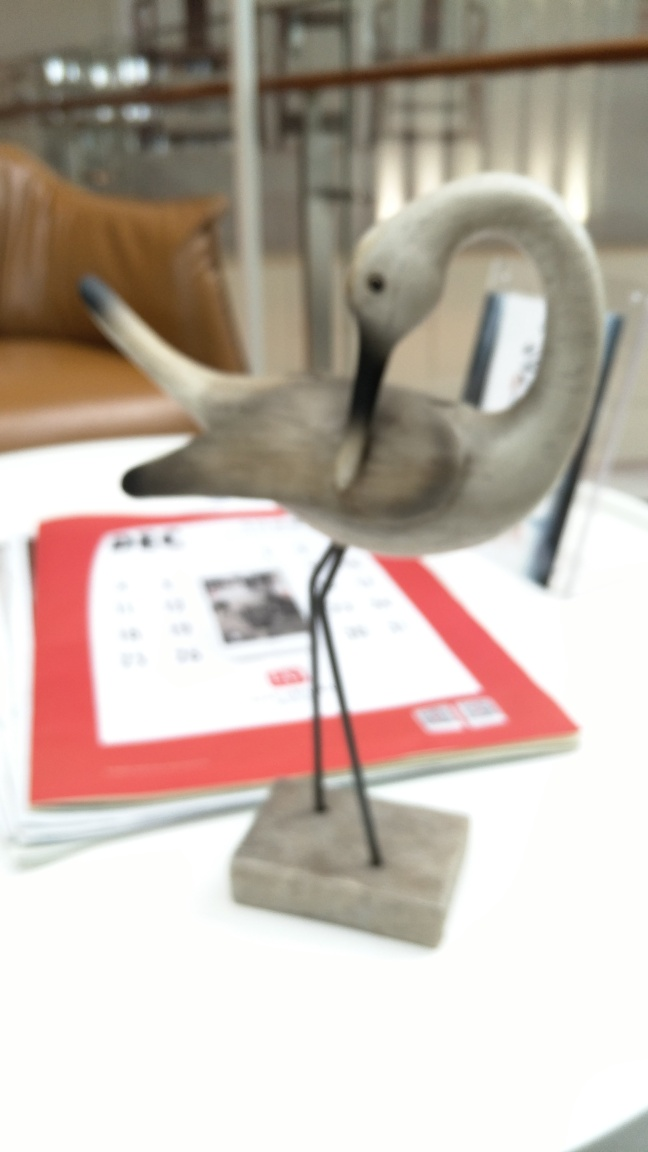Is the main subject, a crane, blurry? Yes, the main subject of the image, which appears to be a model of a crane, is indeed blurry. This could be due to a shallow depth of field or motion blur from the camera movement while the photo was being taken. 